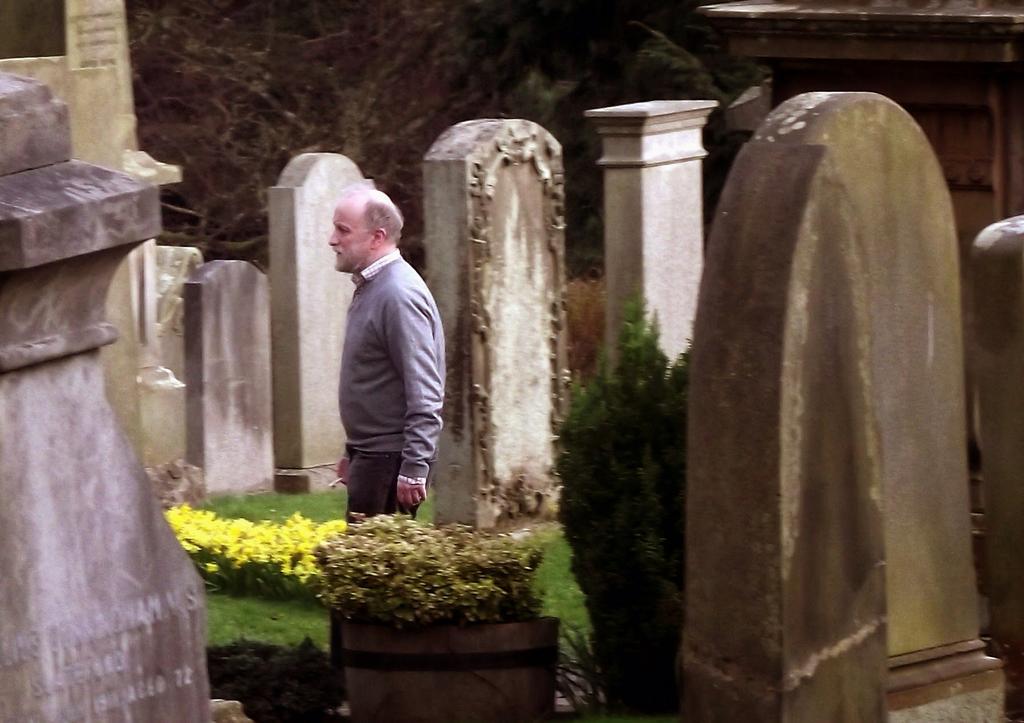In one or two sentences, can you explain what this image depicts? In the picture I can see a man is standing on the ground. I can also see flowers, gravestones, trees and some other objects on the ground. 